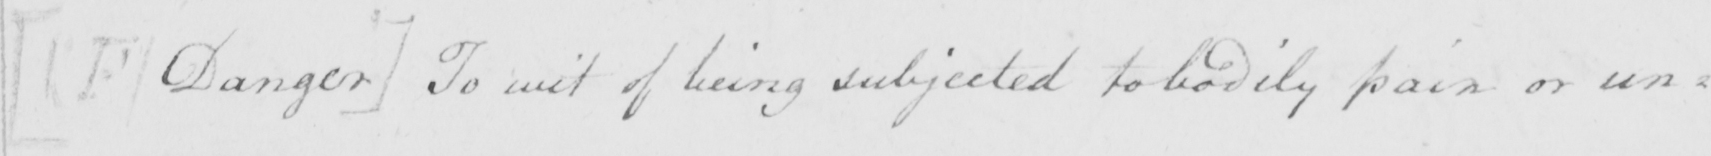Can you tell me what this handwritten text says? [ F Danger ]  To wit of being subjected to bodily pain or un= 